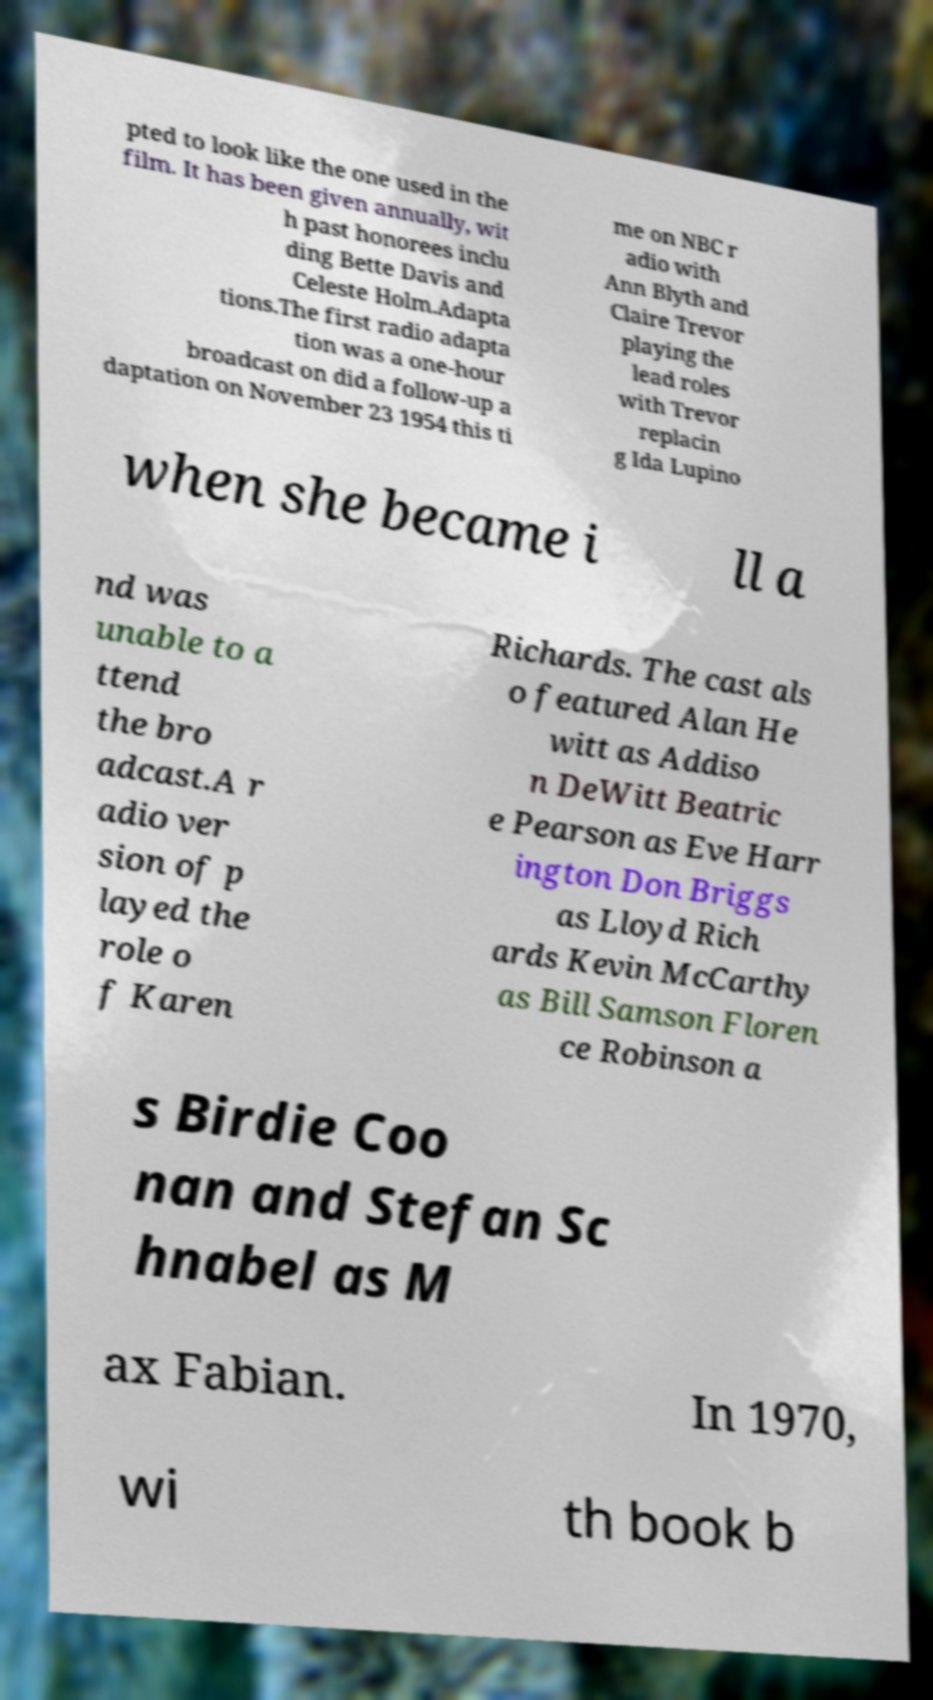There's text embedded in this image that I need extracted. Can you transcribe it verbatim? pted to look like the one used in the film. It has been given annually, wit h past honorees inclu ding Bette Davis and Celeste Holm.Adapta tions.The first radio adapta tion was a one-hour broadcast on did a follow-up a daptation on November 23 1954 this ti me on NBC r adio with Ann Blyth and Claire Trevor playing the lead roles with Trevor replacin g Ida Lupino when she became i ll a nd was unable to a ttend the bro adcast.A r adio ver sion of p layed the role o f Karen Richards. The cast als o featured Alan He witt as Addiso n DeWitt Beatric e Pearson as Eve Harr ington Don Briggs as Lloyd Rich ards Kevin McCarthy as Bill Samson Floren ce Robinson a s Birdie Coo nan and Stefan Sc hnabel as M ax Fabian. In 1970, wi th book b 